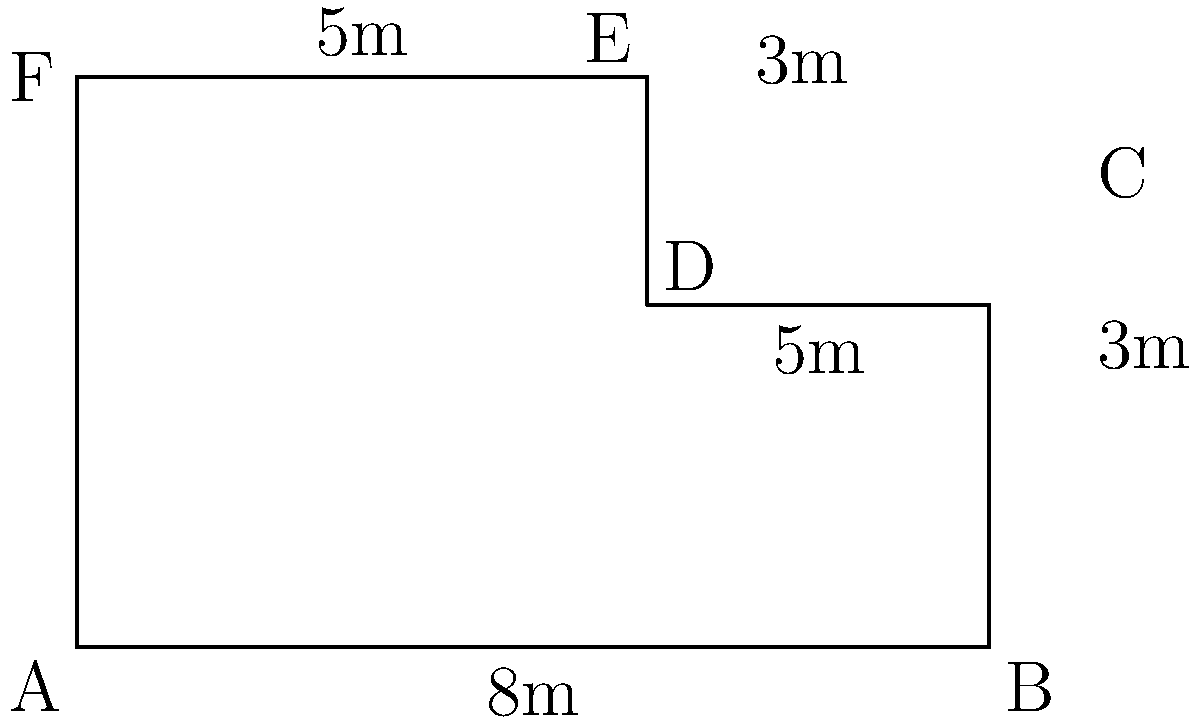A new welfare office building has an irregular shape as shown in the diagram. Calculate the perimeter of this building to determine the length of fencing needed for security purposes. All measurements are in meters. To calculate the perimeter, we need to sum up the lengths of all sides:

1. Side AB: 8m (given)
2. Side BC: 3m (given)
3. Side CD: 5m (given)
4. Side DE: 2m (calculated as 5m - 3m)
5. Side EF: 5m (given)
6. Side FA: 5m (given)

Now, let's sum up all these lengths:

$$ \text{Perimeter} = 8m + 3m + 5m + 2m + 5m + 5m = 28m $$

Therefore, the total perimeter of the welfare office building is 28 meters.
Answer: 28 meters 